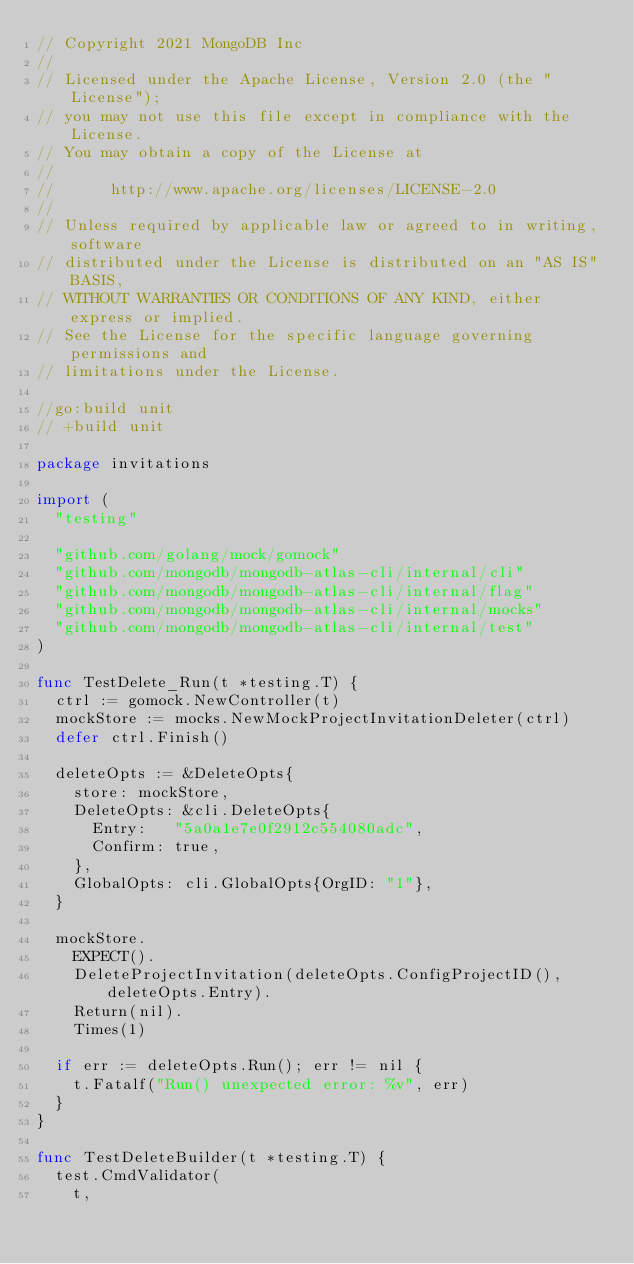Convert code to text. <code><loc_0><loc_0><loc_500><loc_500><_Go_>// Copyright 2021 MongoDB Inc
//
// Licensed under the Apache License, Version 2.0 (the "License");
// you may not use this file except in compliance with the License.
// You may obtain a copy of the License at
//
//      http://www.apache.org/licenses/LICENSE-2.0
//
// Unless required by applicable law or agreed to in writing, software
// distributed under the License is distributed on an "AS IS" BASIS,
// WITHOUT WARRANTIES OR CONDITIONS OF ANY KIND, either express or implied.
// See the License for the specific language governing permissions and
// limitations under the License.

//go:build unit
// +build unit

package invitations

import (
	"testing"

	"github.com/golang/mock/gomock"
	"github.com/mongodb/mongodb-atlas-cli/internal/cli"
	"github.com/mongodb/mongodb-atlas-cli/internal/flag"
	"github.com/mongodb/mongodb-atlas-cli/internal/mocks"
	"github.com/mongodb/mongodb-atlas-cli/internal/test"
)

func TestDelete_Run(t *testing.T) {
	ctrl := gomock.NewController(t)
	mockStore := mocks.NewMockProjectInvitationDeleter(ctrl)
	defer ctrl.Finish()

	deleteOpts := &DeleteOpts{
		store: mockStore,
		DeleteOpts: &cli.DeleteOpts{
			Entry:   "5a0a1e7e0f2912c554080adc",
			Confirm: true,
		},
		GlobalOpts: cli.GlobalOpts{OrgID: "1"},
	}

	mockStore.
		EXPECT().
		DeleteProjectInvitation(deleteOpts.ConfigProjectID(), deleteOpts.Entry).
		Return(nil).
		Times(1)

	if err := deleteOpts.Run(); err != nil {
		t.Fatalf("Run() unexpected error: %v", err)
	}
}

func TestDeleteBuilder(t *testing.T) {
	test.CmdValidator(
		t,</code> 